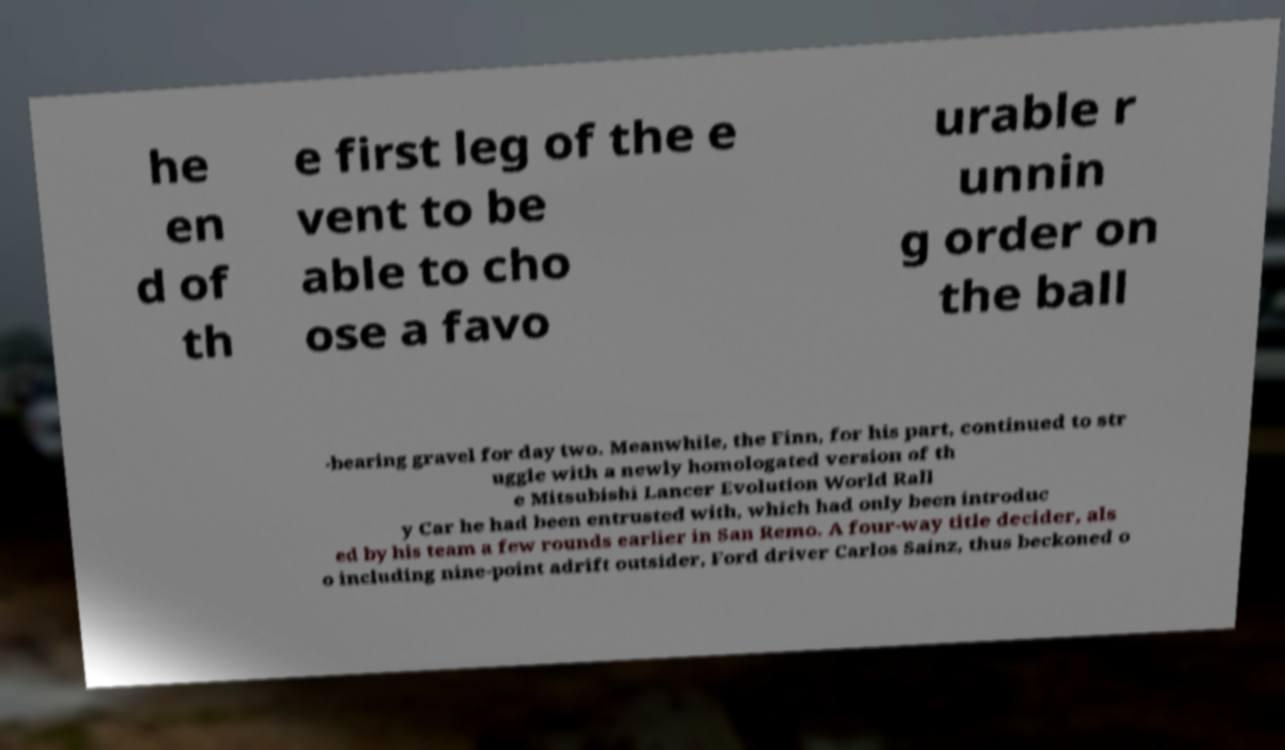Can you read and provide the text displayed in the image?This photo seems to have some interesting text. Can you extract and type it out for me? he en d of th e first leg of the e vent to be able to cho ose a favo urable r unnin g order on the ball -bearing gravel for day two. Meanwhile, the Finn, for his part, continued to str uggle with a newly homologated version of th e Mitsubishi Lancer Evolution World Rall y Car he had been entrusted with, which had only been introduc ed by his team a few rounds earlier in San Remo. A four-way title decider, als o including nine-point adrift outsider, Ford driver Carlos Sainz, thus beckoned o 